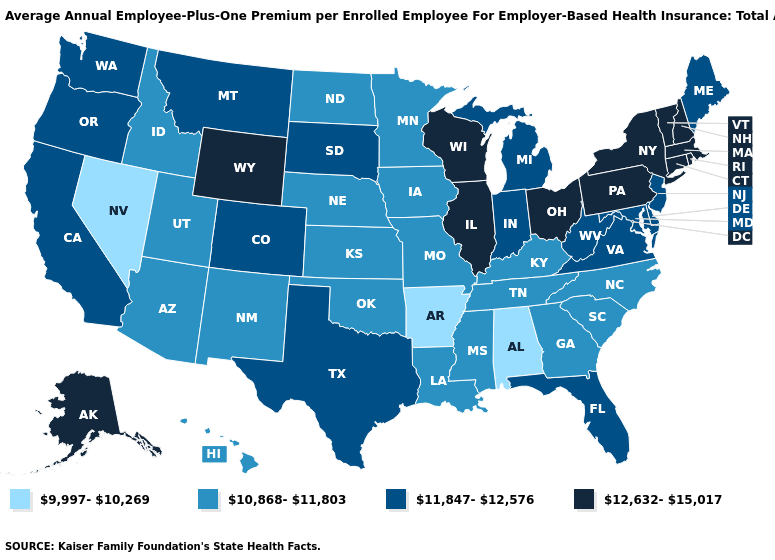Name the states that have a value in the range 12,632-15,017?
Give a very brief answer. Alaska, Connecticut, Illinois, Massachusetts, New Hampshire, New York, Ohio, Pennsylvania, Rhode Island, Vermont, Wisconsin, Wyoming. Does Connecticut have a higher value than Rhode Island?
Answer briefly. No. What is the highest value in states that border Nevada?
Answer briefly. 11,847-12,576. What is the highest value in the South ?
Give a very brief answer. 11,847-12,576. Does Minnesota have the lowest value in the MidWest?
Give a very brief answer. Yes. What is the value of Alaska?
Concise answer only. 12,632-15,017. Name the states that have a value in the range 10,868-11,803?
Quick response, please. Arizona, Georgia, Hawaii, Idaho, Iowa, Kansas, Kentucky, Louisiana, Minnesota, Mississippi, Missouri, Nebraska, New Mexico, North Carolina, North Dakota, Oklahoma, South Carolina, Tennessee, Utah. Does Massachusetts have the highest value in the USA?
Write a very short answer. Yes. Does Louisiana have the lowest value in the USA?
Answer briefly. No. Does Washington have a higher value than Kansas?
Quick response, please. Yes. What is the value of Washington?
Keep it brief. 11,847-12,576. Name the states that have a value in the range 9,997-10,269?
Write a very short answer. Alabama, Arkansas, Nevada. Name the states that have a value in the range 11,847-12,576?
Concise answer only. California, Colorado, Delaware, Florida, Indiana, Maine, Maryland, Michigan, Montana, New Jersey, Oregon, South Dakota, Texas, Virginia, Washington, West Virginia. What is the value of Nebraska?
Be succinct. 10,868-11,803. What is the value of Washington?
Write a very short answer. 11,847-12,576. 